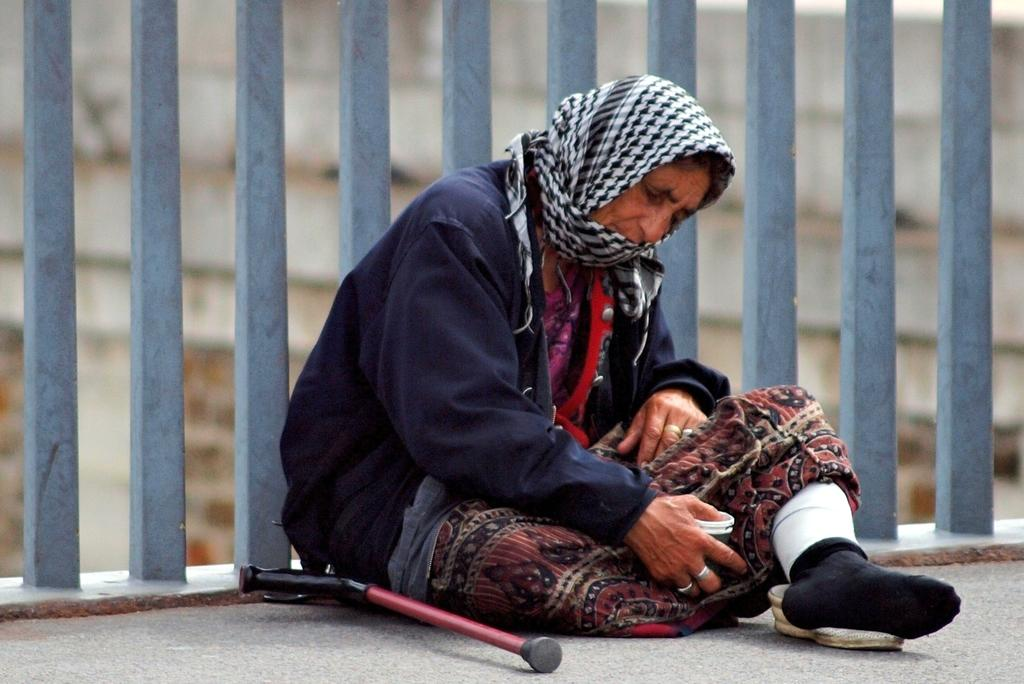What is present in the image that separates or encloses an area? There is a fence in the image. Who is present in the image and where are they located? There is a woman sitting in the image. What can be seen in the distance behind the woman? There is a building in the background of the image. What type of metal is the cup made of in the image? There is no cup present in the image, so it is not possible to determine the type of metal it might be made of. 